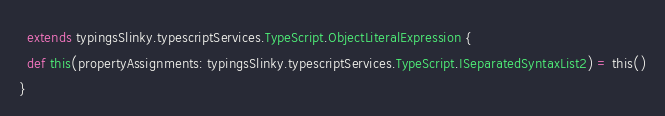<code> <loc_0><loc_0><loc_500><loc_500><_Scala_>  extends typingsSlinky.typescriptServices.TypeScript.ObjectLiteralExpression {
  def this(propertyAssignments: typingsSlinky.typescriptServices.TypeScript.ISeparatedSyntaxList2) = this()
}
</code> 